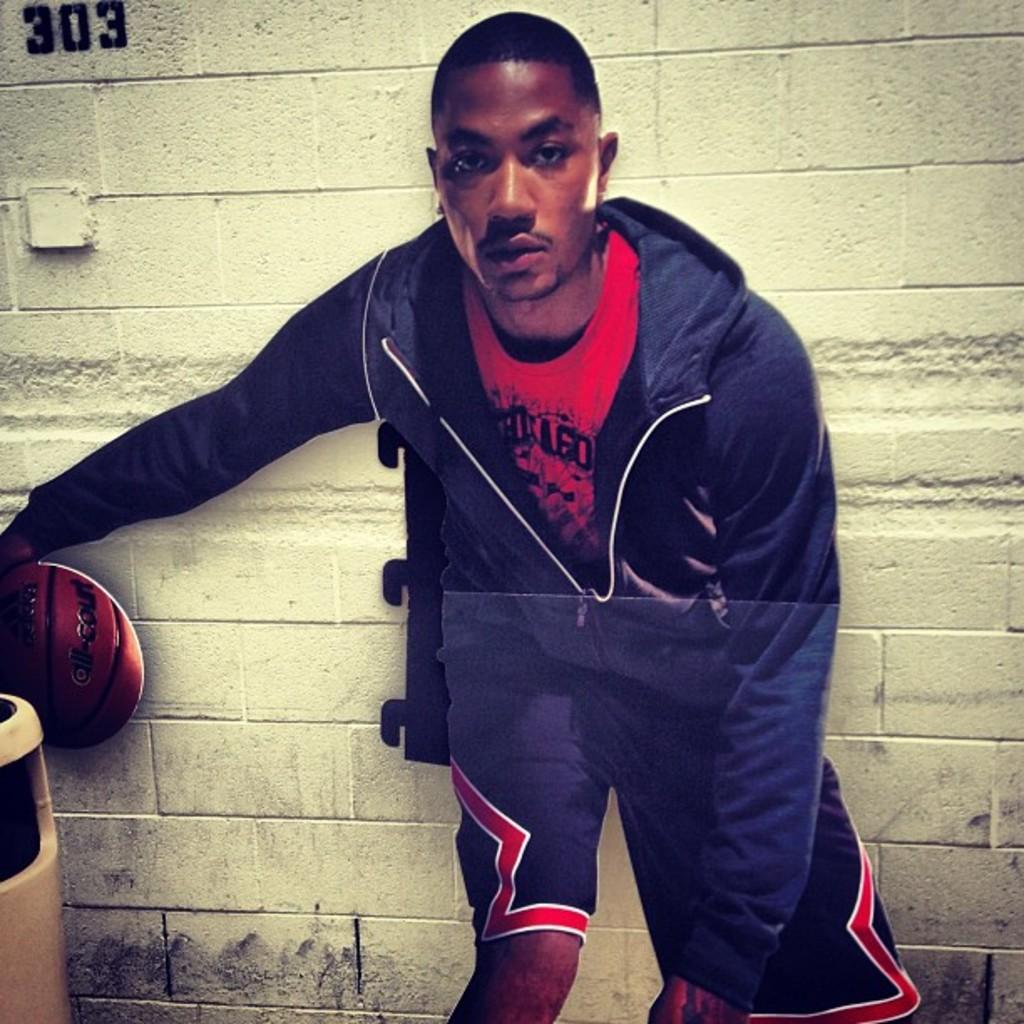What is the room number in the top left corner?
Your answer should be compact. 303. What does it say on the man's shirt?
Provide a short and direct response. Unanswerable. 